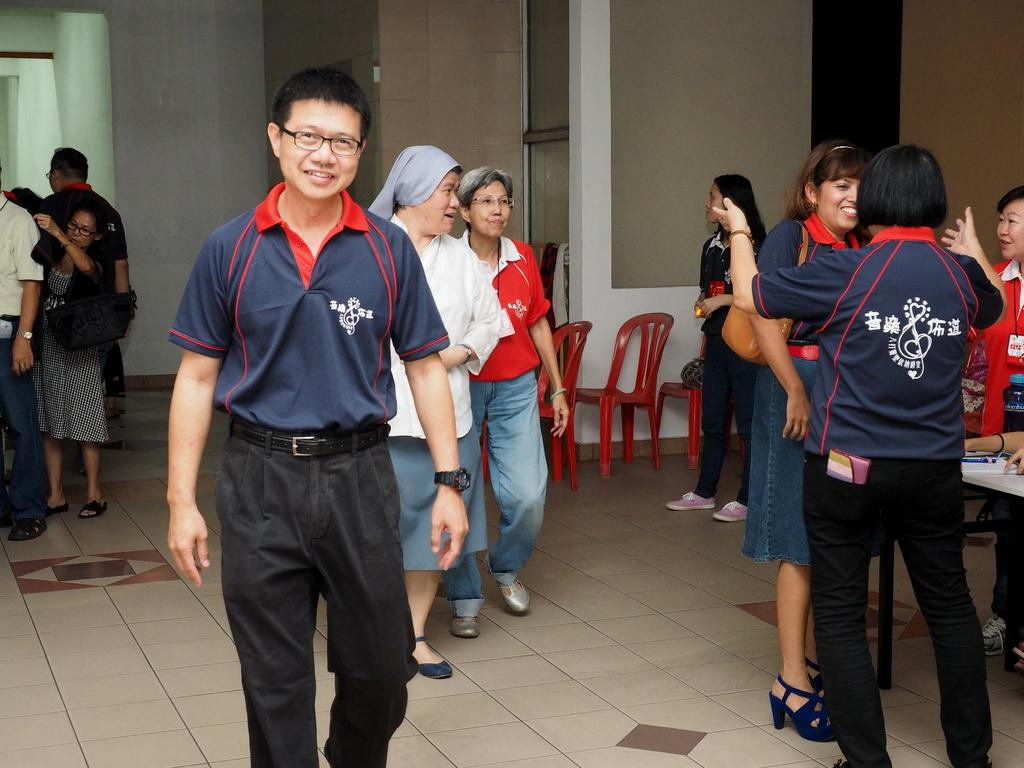What are the people in the image doing? The people in the image are walking. On what surface are the people walking? The people are walking on the floor. What can be seen in the background of the image? There are chairs, a wall, and glass windows in the background of the image. What type of coach can be seen in the image? There is no coach present in the image. 